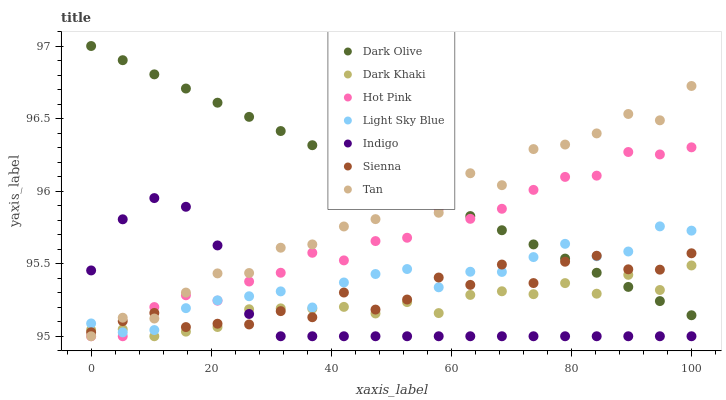Does Indigo have the minimum area under the curve?
Answer yes or no. Yes. Does Dark Olive have the maximum area under the curve?
Answer yes or no. Yes. Does Hot Pink have the minimum area under the curve?
Answer yes or no. No. Does Hot Pink have the maximum area under the curve?
Answer yes or no. No. Is Dark Olive the smoothest?
Answer yes or no. Yes. Is Tan the roughest?
Answer yes or no. Yes. Is Hot Pink the smoothest?
Answer yes or no. No. Is Hot Pink the roughest?
Answer yes or no. No. Does Hot Pink have the lowest value?
Answer yes or no. Yes. Does Dark Olive have the lowest value?
Answer yes or no. No. Does Dark Olive have the highest value?
Answer yes or no. Yes. Does Hot Pink have the highest value?
Answer yes or no. No. Is Indigo less than Dark Olive?
Answer yes or no. Yes. Is Dark Olive greater than Indigo?
Answer yes or no. Yes. Does Dark Olive intersect Light Sky Blue?
Answer yes or no. Yes. Is Dark Olive less than Light Sky Blue?
Answer yes or no. No. Is Dark Olive greater than Light Sky Blue?
Answer yes or no. No. Does Indigo intersect Dark Olive?
Answer yes or no. No. 